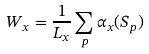<formula> <loc_0><loc_0><loc_500><loc_500>W _ { x } = \frac { 1 } { L _ { x } } \sum _ { p } \alpha _ { x } ( S _ { p } )</formula> 